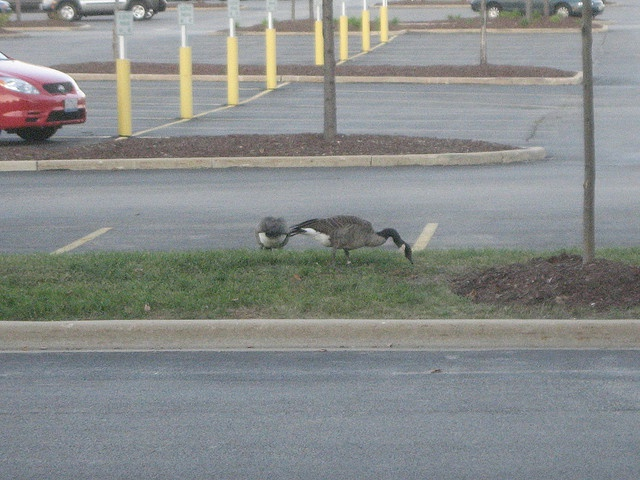Describe the objects in this image and their specific colors. I can see car in lightgray, brown, lavender, black, and darkgray tones, bird in lightgray, gray, darkgray, and black tones, car in lightgray, gray, and darkgray tones, car in lightgray, gray, and darkgray tones, and bird in lightgray, gray, darkgray, and black tones in this image. 